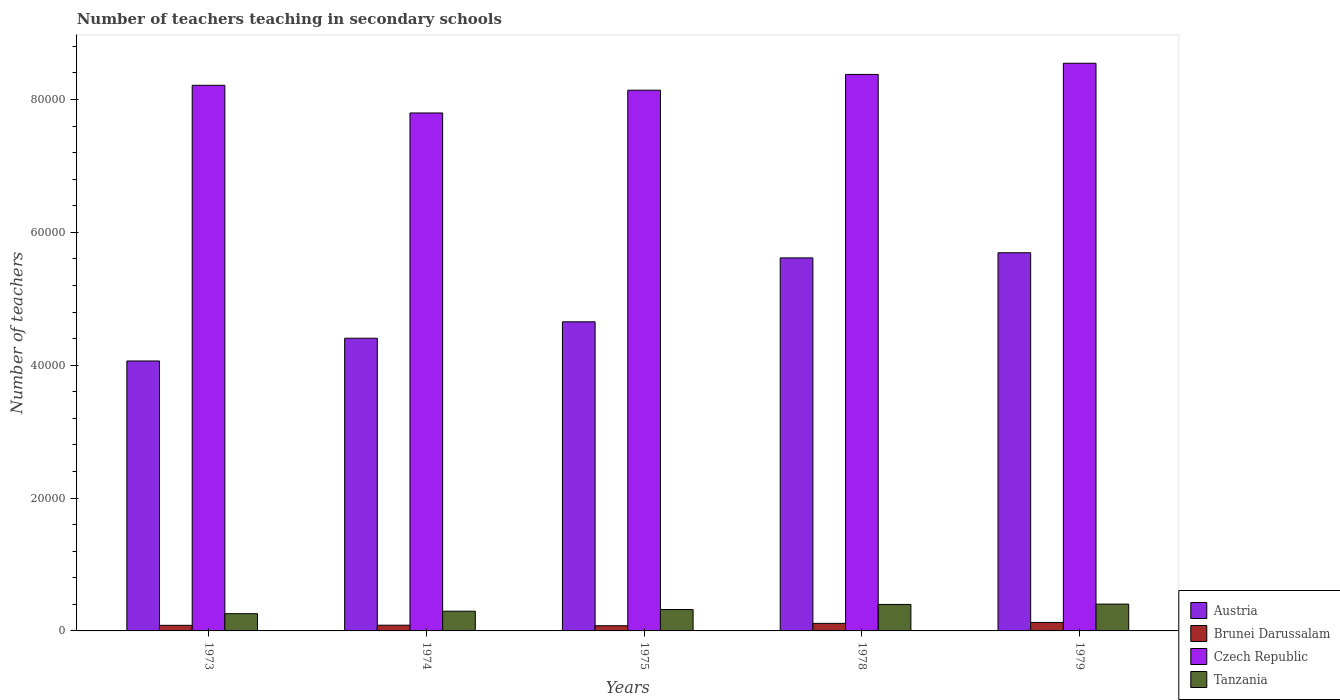How many groups of bars are there?
Make the answer very short. 5. How many bars are there on the 2nd tick from the left?
Offer a terse response. 4. What is the label of the 5th group of bars from the left?
Your answer should be very brief. 1979. What is the number of teachers teaching in secondary schools in Tanzania in 1973?
Give a very brief answer. 2596. Across all years, what is the maximum number of teachers teaching in secondary schools in Czech Republic?
Make the answer very short. 8.55e+04. Across all years, what is the minimum number of teachers teaching in secondary schools in Austria?
Give a very brief answer. 4.06e+04. In which year was the number of teachers teaching in secondary schools in Brunei Darussalam maximum?
Your response must be concise. 1979. In which year was the number of teachers teaching in secondary schools in Czech Republic minimum?
Make the answer very short. 1974. What is the total number of teachers teaching in secondary schools in Brunei Darussalam in the graph?
Offer a very short reply. 4899. What is the difference between the number of teachers teaching in secondary schools in Tanzania in 1974 and that in 1978?
Keep it short and to the point. -1018. What is the difference between the number of teachers teaching in secondary schools in Austria in 1974 and the number of teachers teaching in secondary schools in Czech Republic in 1979?
Give a very brief answer. -4.14e+04. What is the average number of teachers teaching in secondary schools in Brunei Darussalam per year?
Give a very brief answer. 979.8. In the year 1975, what is the difference between the number of teachers teaching in secondary schools in Austria and number of teachers teaching in secondary schools in Tanzania?
Offer a terse response. 4.33e+04. In how many years, is the number of teachers teaching in secondary schools in Brunei Darussalam greater than 20000?
Keep it short and to the point. 0. What is the ratio of the number of teachers teaching in secondary schools in Brunei Darussalam in 1975 to that in 1978?
Give a very brief answer. 0.69. What is the difference between the highest and the second highest number of teachers teaching in secondary schools in Czech Republic?
Your answer should be compact. 1681. What is the difference between the highest and the lowest number of teachers teaching in secondary schools in Tanzania?
Your answer should be very brief. 1442. Is the sum of the number of teachers teaching in secondary schools in Brunei Darussalam in 1973 and 1978 greater than the maximum number of teachers teaching in secondary schools in Austria across all years?
Your response must be concise. No. What does the 1st bar from the left in 1975 represents?
Offer a very short reply. Austria. Is it the case that in every year, the sum of the number of teachers teaching in secondary schools in Brunei Darussalam and number of teachers teaching in secondary schools in Tanzania is greater than the number of teachers teaching in secondary schools in Czech Republic?
Provide a short and direct response. No. How many bars are there?
Ensure brevity in your answer.  20. Are all the bars in the graph horizontal?
Your answer should be compact. No. How many years are there in the graph?
Make the answer very short. 5. Are the values on the major ticks of Y-axis written in scientific E-notation?
Ensure brevity in your answer.  No. Does the graph contain any zero values?
Provide a succinct answer. No. What is the title of the graph?
Your answer should be compact. Number of teachers teaching in secondary schools. Does "Mauritius" appear as one of the legend labels in the graph?
Make the answer very short. No. What is the label or title of the Y-axis?
Provide a short and direct response. Number of teachers. What is the Number of teachers in Austria in 1973?
Keep it short and to the point. 4.06e+04. What is the Number of teachers of Brunei Darussalam in 1973?
Provide a succinct answer. 844. What is the Number of teachers in Czech Republic in 1973?
Make the answer very short. 8.21e+04. What is the Number of teachers of Tanzania in 1973?
Keep it short and to the point. 2596. What is the Number of teachers in Austria in 1974?
Ensure brevity in your answer.  4.41e+04. What is the Number of teachers of Brunei Darussalam in 1974?
Your answer should be very brief. 859. What is the Number of teachers of Czech Republic in 1974?
Give a very brief answer. 7.80e+04. What is the Number of teachers of Tanzania in 1974?
Ensure brevity in your answer.  2967. What is the Number of teachers in Austria in 1975?
Make the answer very short. 4.65e+04. What is the Number of teachers in Brunei Darussalam in 1975?
Your answer should be compact. 782. What is the Number of teachers in Czech Republic in 1975?
Offer a terse response. 8.14e+04. What is the Number of teachers of Tanzania in 1975?
Your answer should be compact. 3218. What is the Number of teachers in Austria in 1978?
Your answer should be very brief. 5.62e+04. What is the Number of teachers in Brunei Darussalam in 1978?
Ensure brevity in your answer.  1138. What is the Number of teachers in Czech Republic in 1978?
Your answer should be very brief. 8.38e+04. What is the Number of teachers in Tanzania in 1978?
Keep it short and to the point. 3985. What is the Number of teachers in Austria in 1979?
Provide a succinct answer. 5.69e+04. What is the Number of teachers of Brunei Darussalam in 1979?
Your answer should be very brief. 1276. What is the Number of teachers in Czech Republic in 1979?
Offer a terse response. 8.55e+04. What is the Number of teachers in Tanzania in 1979?
Give a very brief answer. 4038. Across all years, what is the maximum Number of teachers of Austria?
Your response must be concise. 5.69e+04. Across all years, what is the maximum Number of teachers in Brunei Darussalam?
Your answer should be very brief. 1276. Across all years, what is the maximum Number of teachers of Czech Republic?
Ensure brevity in your answer.  8.55e+04. Across all years, what is the maximum Number of teachers in Tanzania?
Your answer should be very brief. 4038. Across all years, what is the minimum Number of teachers in Austria?
Provide a succinct answer. 4.06e+04. Across all years, what is the minimum Number of teachers in Brunei Darussalam?
Provide a succinct answer. 782. Across all years, what is the minimum Number of teachers of Czech Republic?
Give a very brief answer. 7.80e+04. Across all years, what is the minimum Number of teachers of Tanzania?
Make the answer very short. 2596. What is the total Number of teachers in Austria in the graph?
Keep it short and to the point. 2.44e+05. What is the total Number of teachers in Brunei Darussalam in the graph?
Offer a very short reply. 4899. What is the total Number of teachers of Czech Republic in the graph?
Offer a terse response. 4.11e+05. What is the total Number of teachers of Tanzania in the graph?
Your answer should be compact. 1.68e+04. What is the difference between the Number of teachers in Austria in 1973 and that in 1974?
Provide a succinct answer. -3423. What is the difference between the Number of teachers of Brunei Darussalam in 1973 and that in 1974?
Make the answer very short. -15. What is the difference between the Number of teachers of Czech Republic in 1973 and that in 1974?
Offer a terse response. 4167. What is the difference between the Number of teachers of Tanzania in 1973 and that in 1974?
Offer a very short reply. -371. What is the difference between the Number of teachers in Austria in 1973 and that in 1975?
Offer a very short reply. -5897. What is the difference between the Number of teachers in Czech Republic in 1973 and that in 1975?
Your answer should be compact. 741. What is the difference between the Number of teachers of Tanzania in 1973 and that in 1975?
Provide a succinct answer. -622. What is the difference between the Number of teachers of Austria in 1973 and that in 1978?
Offer a very short reply. -1.55e+04. What is the difference between the Number of teachers of Brunei Darussalam in 1973 and that in 1978?
Offer a terse response. -294. What is the difference between the Number of teachers in Czech Republic in 1973 and that in 1978?
Your answer should be compact. -1635. What is the difference between the Number of teachers in Tanzania in 1973 and that in 1978?
Your answer should be very brief. -1389. What is the difference between the Number of teachers of Austria in 1973 and that in 1979?
Your answer should be compact. -1.63e+04. What is the difference between the Number of teachers in Brunei Darussalam in 1973 and that in 1979?
Offer a terse response. -432. What is the difference between the Number of teachers of Czech Republic in 1973 and that in 1979?
Make the answer very short. -3316. What is the difference between the Number of teachers in Tanzania in 1973 and that in 1979?
Give a very brief answer. -1442. What is the difference between the Number of teachers in Austria in 1974 and that in 1975?
Your answer should be compact. -2474. What is the difference between the Number of teachers of Brunei Darussalam in 1974 and that in 1975?
Give a very brief answer. 77. What is the difference between the Number of teachers in Czech Republic in 1974 and that in 1975?
Give a very brief answer. -3426. What is the difference between the Number of teachers of Tanzania in 1974 and that in 1975?
Make the answer very short. -251. What is the difference between the Number of teachers in Austria in 1974 and that in 1978?
Give a very brief answer. -1.21e+04. What is the difference between the Number of teachers of Brunei Darussalam in 1974 and that in 1978?
Provide a short and direct response. -279. What is the difference between the Number of teachers in Czech Republic in 1974 and that in 1978?
Your answer should be compact. -5802. What is the difference between the Number of teachers in Tanzania in 1974 and that in 1978?
Keep it short and to the point. -1018. What is the difference between the Number of teachers of Austria in 1974 and that in 1979?
Offer a very short reply. -1.29e+04. What is the difference between the Number of teachers in Brunei Darussalam in 1974 and that in 1979?
Offer a very short reply. -417. What is the difference between the Number of teachers in Czech Republic in 1974 and that in 1979?
Your answer should be very brief. -7483. What is the difference between the Number of teachers in Tanzania in 1974 and that in 1979?
Your response must be concise. -1071. What is the difference between the Number of teachers of Austria in 1975 and that in 1978?
Provide a succinct answer. -9620. What is the difference between the Number of teachers in Brunei Darussalam in 1975 and that in 1978?
Provide a succinct answer. -356. What is the difference between the Number of teachers in Czech Republic in 1975 and that in 1978?
Offer a terse response. -2376. What is the difference between the Number of teachers in Tanzania in 1975 and that in 1978?
Ensure brevity in your answer.  -767. What is the difference between the Number of teachers in Austria in 1975 and that in 1979?
Give a very brief answer. -1.04e+04. What is the difference between the Number of teachers of Brunei Darussalam in 1975 and that in 1979?
Keep it short and to the point. -494. What is the difference between the Number of teachers of Czech Republic in 1975 and that in 1979?
Your answer should be compact. -4057. What is the difference between the Number of teachers of Tanzania in 1975 and that in 1979?
Your response must be concise. -820. What is the difference between the Number of teachers of Austria in 1978 and that in 1979?
Make the answer very short. -776. What is the difference between the Number of teachers in Brunei Darussalam in 1978 and that in 1979?
Keep it short and to the point. -138. What is the difference between the Number of teachers in Czech Republic in 1978 and that in 1979?
Your response must be concise. -1681. What is the difference between the Number of teachers in Tanzania in 1978 and that in 1979?
Ensure brevity in your answer.  -53. What is the difference between the Number of teachers of Austria in 1973 and the Number of teachers of Brunei Darussalam in 1974?
Make the answer very short. 3.98e+04. What is the difference between the Number of teachers in Austria in 1973 and the Number of teachers in Czech Republic in 1974?
Your answer should be compact. -3.73e+04. What is the difference between the Number of teachers of Austria in 1973 and the Number of teachers of Tanzania in 1974?
Keep it short and to the point. 3.77e+04. What is the difference between the Number of teachers in Brunei Darussalam in 1973 and the Number of teachers in Czech Republic in 1974?
Your answer should be compact. -7.71e+04. What is the difference between the Number of teachers in Brunei Darussalam in 1973 and the Number of teachers in Tanzania in 1974?
Give a very brief answer. -2123. What is the difference between the Number of teachers in Czech Republic in 1973 and the Number of teachers in Tanzania in 1974?
Provide a succinct answer. 7.92e+04. What is the difference between the Number of teachers of Austria in 1973 and the Number of teachers of Brunei Darussalam in 1975?
Your answer should be very brief. 3.99e+04. What is the difference between the Number of teachers of Austria in 1973 and the Number of teachers of Czech Republic in 1975?
Offer a very short reply. -4.08e+04. What is the difference between the Number of teachers in Austria in 1973 and the Number of teachers in Tanzania in 1975?
Offer a very short reply. 3.74e+04. What is the difference between the Number of teachers of Brunei Darussalam in 1973 and the Number of teachers of Czech Republic in 1975?
Offer a very short reply. -8.06e+04. What is the difference between the Number of teachers in Brunei Darussalam in 1973 and the Number of teachers in Tanzania in 1975?
Offer a very short reply. -2374. What is the difference between the Number of teachers in Czech Republic in 1973 and the Number of teachers in Tanzania in 1975?
Offer a terse response. 7.89e+04. What is the difference between the Number of teachers of Austria in 1973 and the Number of teachers of Brunei Darussalam in 1978?
Your response must be concise. 3.95e+04. What is the difference between the Number of teachers in Austria in 1973 and the Number of teachers in Czech Republic in 1978?
Make the answer very short. -4.31e+04. What is the difference between the Number of teachers in Austria in 1973 and the Number of teachers in Tanzania in 1978?
Offer a very short reply. 3.66e+04. What is the difference between the Number of teachers in Brunei Darussalam in 1973 and the Number of teachers in Czech Republic in 1978?
Make the answer very short. -8.29e+04. What is the difference between the Number of teachers in Brunei Darussalam in 1973 and the Number of teachers in Tanzania in 1978?
Make the answer very short. -3141. What is the difference between the Number of teachers of Czech Republic in 1973 and the Number of teachers of Tanzania in 1978?
Offer a very short reply. 7.82e+04. What is the difference between the Number of teachers in Austria in 1973 and the Number of teachers in Brunei Darussalam in 1979?
Offer a very short reply. 3.94e+04. What is the difference between the Number of teachers of Austria in 1973 and the Number of teachers of Czech Republic in 1979?
Provide a succinct answer. -4.48e+04. What is the difference between the Number of teachers of Austria in 1973 and the Number of teachers of Tanzania in 1979?
Make the answer very short. 3.66e+04. What is the difference between the Number of teachers in Brunei Darussalam in 1973 and the Number of teachers in Czech Republic in 1979?
Provide a short and direct response. -8.46e+04. What is the difference between the Number of teachers in Brunei Darussalam in 1973 and the Number of teachers in Tanzania in 1979?
Make the answer very short. -3194. What is the difference between the Number of teachers in Czech Republic in 1973 and the Number of teachers in Tanzania in 1979?
Give a very brief answer. 7.81e+04. What is the difference between the Number of teachers in Austria in 1974 and the Number of teachers in Brunei Darussalam in 1975?
Ensure brevity in your answer.  4.33e+04. What is the difference between the Number of teachers in Austria in 1974 and the Number of teachers in Czech Republic in 1975?
Your answer should be compact. -3.73e+04. What is the difference between the Number of teachers in Austria in 1974 and the Number of teachers in Tanzania in 1975?
Offer a very short reply. 4.08e+04. What is the difference between the Number of teachers of Brunei Darussalam in 1974 and the Number of teachers of Czech Republic in 1975?
Provide a short and direct response. -8.05e+04. What is the difference between the Number of teachers of Brunei Darussalam in 1974 and the Number of teachers of Tanzania in 1975?
Give a very brief answer. -2359. What is the difference between the Number of teachers in Czech Republic in 1974 and the Number of teachers in Tanzania in 1975?
Ensure brevity in your answer.  7.48e+04. What is the difference between the Number of teachers of Austria in 1974 and the Number of teachers of Brunei Darussalam in 1978?
Provide a succinct answer. 4.29e+04. What is the difference between the Number of teachers in Austria in 1974 and the Number of teachers in Czech Republic in 1978?
Offer a very short reply. -3.97e+04. What is the difference between the Number of teachers of Austria in 1974 and the Number of teachers of Tanzania in 1978?
Your answer should be compact. 4.01e+04. What is the difference between the Number of teachers in Brunei Darussalam in 1974 and the Number of teachers in Czech Republic in 1978?
Offer a very short reply. -8.29e+04. What is the difference between the Number of teachers of Brunei Darussalam in 1974 and the Number of teachers of Tanzania in 1978?
Your response must be concise. -3126. What is the difference between the Number of teachers of Czech Republic in 1974 and the Number of teachers of Tanzania in 1978?
Offer a very short reply. 7.40e+04. What is the difference between the Number of teachers of Austria in 1974 and the Number of teachers of Brunei Darussalam in 1979?
Your answer should be very brief. 4.28e+04. What is the difference between the Number of teachers in Austria in 1974 and the Number of teachers in Czech Republic in 1979?
Offer a terse response. -4.14e+04. What is the difference between the Number of teachers of Austria in 1974 and the Number of teachers of Tanzania in 1979?
Your answer should be very brief. 4.00e+04. What is the difference between the Number of teachers of Brunei Darussalam in 1974 and the Number of teachers of Czech Republic in 1979?
Your response must be concise. -8.46e+04. What is the difference between the Number of teachers of Brunei Darussalam in 1974 and the Number of teachers of Tanzania in 1979?
Give a very brief answer. -3179. What is the difference between the Number of teachers in Czech Republic in 1974 and the Number of teachers in Tanzania in 1979?
Offer a terse response. 7.39e+04. What is the difference between the Number of teachers of Austria in 1975 and the Number of teachers of Brunei Darussalam in 1978?
Keep it short and to the point. 4.54e+04. What is the difference between the Number of teachers of Austria in 1975 and the Number of teachers of Czech Republic in 1978?
Keep it short and to the point. -3.72e+04. What is the difference between the Number of teachers in Austria in 1975 and the Number of teachers in Tanzania in 1978?
Your answer should be compact. 4.25e+04. What is the difference between the Number of teachers in Brunei Darussalam in 1975 and the Number of teachers in Czech Republic in 1978?
Provide a short and direct response. -8.30e+04. What is the difference between the Number of teachers in Brunei Darussalam in 1975 and the Number of teachers in Tanzania in 1978?
Offer a very short reply. -3203. What is the difference between the Number of teachers of Czech Republic in 1975 and the Number of teachers of Tanzania in 1978?
Provide a short and direct response. 7.74e+04. What is the difference between the Number of teachers in Austria in 1975 and the Number of teachers in Brunei Darussalam in 1979?
Offer a very short reply. 4.53e+04. What is the difference between the Number of teachers of Austria in 1975 and the Number of teachers of Czech Republic in 1979?
Ensure brevity in your answer.  -3.89e+04. What is the difference between the Number of teachers in Austria in 1975 and the Number of teachers in Tanzania in 1979?
Give a very brief answer. 4.25e+04. What is the difference between the Number of teachers in Brunei Darussalam in 1975 and the Number of teachers in Czech Republic in 1979?
Your answer should be compact. -8.47e+04. What is the difference between the Number of teachers of Brunei Darussalam in 1975 and the Number of teachers of Tanzania in 1979?
Ensure brevity in your answer.  -3256. What is the difference between the Number of teachers of Czech Republic in 1975 and the Number of teachers of Tanzania in 1979?
Offer a terse response. 7.74e+04. What is the difference between the Number of teachers in Austria in 1978 and the Number of teachers in Brunei Darussalam in 1979?
Provide a succinct answer. 5.49e+04. What is the difference between the Number of teachers of Austria in 1978 and the Number of teachers of Czech Republic in 1979?
Offer a terse response. -2.93e+04. What is the difference between the Number of teachers of Austria in 1978 and the Number of teachers of Tanzania in 1979?
Offer a terse response. 5.21e+04. What is the difference between the Number of teachers of Brunei Darussalam in 1978 and the Number of teachers of Czech Republic in 1979?
Your response must be concise. -8.43e+04. What is the difference between the Number of teachers in Brunei Darussalam in 1978 and the Number of teachers in Tanzania in 1979?
Ensure brevity in your answer.  -2900. What is the difference between the Number of teachers in Czech Republic in 1978 and the Number of teachers in Tanzania in 1979?
Ensure brevity in your answer.  7.97e+04. What is the average Number of teachers in Austria per year?
Provide a succinct answer. 4.89e+04. What is the average Number of teachers in Brunei Darussalam per year?
Provide a succinct answer. 979.8. What is the average Number of teachers in Czech Republic per year?
Your response must be concise. 8.21e+04. What is the average Number of teachers in Tanzania per year?
Your answer should be compact. 3360.8. In the year 1973, what is the difference between the Number of teachers of Austria and Number of teachers of Brunei Darussalam?
Your answer should be compact. 3.98e+04. In the year 1973, what is the difference between the Number of teachers of Austria and Number of teachers of Czech Republic?
Provide a succinct answer. -4.15e+04. In the year 1973, what is the difference between the Number of teachers of Austria and Number of teachers of Tanzania?
Offer a terse response. 3.80e+04. In the year 1973, what is the difference between the Number of teachers of Brunei Darussalam and Number of teachers of Czech Republic?
Offer a terse response. -8.13e+04. In the year 1973, what is the difference between the Number of teachers in Brunei Darussalam and Number of teachers in Tanzania?
Offer a terse response. -1752. In the year 1973, what is the difference between the Number of teachers in Czech Republic and Number of teachers in Tanzania?
Your response must be concise. 7.95e+04. In the year 1974, what is the difference between the Number of teachers in Austria and Number of teachers in Brunei Darussalam?
Your response must be concise. 4.32e+04. In the year 1974, what is the difference between the Number of teachers of Austria and Number of teachers of Czech Republic?
Your answer should be compact. -3.39e+04. In the year 1974, what is the difference between the Number of teachers in Austria and Number of teachers in Tanzania?
Provide a succinct answer. 4.11e+04. In the year 1974, what is the difference between the Number of teachers in Brunei Darussalam and Number of teachers in Czech Republic?
Your answer should be compact. -7.71e+04. In the year 1974, what is the difference between the Number of teachers of Brunei Darussalam and Number of teachers of Tanzania?
Offer a terse response. -2108. In the year 1974, what is the difference between the Number of teachers of Czech Republic and Number of teachers of Tanzania?
Keep it short and to the point. 7.50e+04. In the year 1975, what is the difference between the Number of teachers of Austria and Number of teachers of Brunei Darussalam?
Give a very brief answer. 4.57e+04. In the year 1975, what is the difference between the Number of teachers in Austria and Number of teachers in Czech Republic?
Provide a succinct answer. -3.49e+04. In the year 1975, what is the difference between the Number of teachers in Austria and Number of teachers in Tanzania?
Ensure brevity in your answer.  4.33e+04. In the year 1975, what is the difference between the Number of teachers of Brunei Darussalam and Number of teachers of Czech Republic?
Your response must be concise. -8.06e+04. In the year 1975, what is the difference between the Number of teachers in Brunei Darussalam and Number of teachers in Tanzania?
Provide a succinct answer. -2436. In the year 1975, what is the difference between the Number of teachers in Czech Republic and Number of teachers in Tanzania?
Offer a very short reply. 7.82e+04. In the year 1978, what is the difference between the Number of teachers in Austria and Number of teachers in Brunei Darussalam?
Give a very brief answer. 5.50e+04. In the year 1978, what is the difference between the Number of teachers in Austria and Number of teachers in Czech Republic?
Your answer should be compact. -2.76e+04. In the year 1978, what is the difference between the Number of teachers in Austria and Number of teachers in Tanzania?
Offer a terse response. 5.22e+04. In the year 1978, what is the difference between the Number of teachers in Brunei Darussalam and Number of teachers in Czech Republic?
Ensure brevity in your answer.  -8.26e+04. In the year 1978, what is the difference between the Number of teachers in Brunei Darussalam and Number of teachers in Tanzania?
Your answer should be compact. -2847. In the year 1978, what is the difference between the Number of teachers of Czech Republic and Number of teachers of Tanzania?
Keep it short and to the point. 7.98e+04. In the year 1979, what is the difference between the Number of teachers in Austria and Number of teachers in Brunei Darussalam?
Your response must be concise. 5.57e+04. In the year 1979, what is the difference between the Number of teachers in Austria and Number of teachers in Czech Republic?
Your answer should be compact. -2.85e+04. In the year 1979, what is the difference between the Number of teachers of Austria and Number of teachers of Tanzania?
Your response must be concise. 5.29e+04. In the year 1979, what is the difference between the Number of teachers in Brunei Darussalam and Number of teachers in Czech Republic?
Make the answer very short. -8.42e+04. In the year 1979, what is the difference between the Number of teachers of Brunei Darussalam and Number of teachers of Tanzania?
Provide a succinct answer. -2762. In the year 1979, what is the difference between the Number of teachers of Czech Republic and Number of teachers of Tanzania?
Provide a succinct answer. 8.14e+04. What is the ratio of the Number of teachers in Austria in 1973 to that in 1974?
Provide a succinct answer. 0.92. What is the ratio of the Number of teachers of Brunei Darussalam in 1973 to that in 1974?
Your response must be concise. 0.98. What is the ratio of the Number of teachers in Czech Republic in 1973 to that in 1974?
Make the answer very short. 1.05. What is the ratio of the Number of teachers of Austria in 1973 to that in 1975?
Ensure brevity in your answer.  0.87. What is the ratio of the Number of teachers in Brunei Darussalam in 1973 to that in 1975?
Keep it short and to the point. 1.08. What is the ratio of the Number of teachers of Czech Republic in 1973 to that in 1975?
Keep it short and to the point. 1.01. What is the ratio of the Number of teachers in Tanzania in 1973 to that in 1975?
Your response must be concise. 0.81. What is the ratio of the Number of teachers in Austria in 1973 to that in 1978?
Keep it short and to the point. 0.72. What is the ratio of the Number of teachers in Brunei Darussalam in 1973 to that in 1978?
Provide a short and direct response. 0.74. What is the ratio of the Number of teachers in Czech Republic in 1973 to that in 1978?
Your answer should be compact. 0.98. What is the ratio of the Number of teachers of Tanzania in 1973 to that in 1978?
Offer a very short reply. 0.65. What is the ratio of the Number of teachers of Austria in 1973 to that in 1979?
Your answer should be compact. 0.71. What is the ratio of the Number of teachers of Brunei Darussalam in 1973 to that in 1979?
Provide a succinct answer. 0.66. What is the ratio of the Number of teachers of Czech Republic in 1973 to that in 1979?
Provide a succinct answer. 0.96. What is the ratio of the Number of teachers of Tanzania in 1973 to that in 1979?
Provide a succinct answer. 0.64. What is the ratio of the Number of teachers in Austria in 1974 to that in 1975?
Provide a short and direct response. 0.95. What is the ratio of the Number of teachers of Brunei Darussalam in 1974 to that in 1975?
Provide a short and direct response. 1.1. What is the ratio of the Number of teachers of Czech Republic in 1974 to that in 1975?
Give a very brief answer. 0.96. What is the ratio of the Number of teachers in Tanzania in 1974 to that in 1975?
Make the answer very short. 0.92. What is the ratio of the Number of teachers of Austria in 1974 to that in 1978?
Ensure brevity in your answer.  0.78. What is the ratio of the Number of teachers in Brunei Darussalam in 1974 to that in 1978?
Provide a succinct answer. 0.75. What is the ratio of the Number of teachers of Czech Republic in 1974 to that in 1978?
Ensure brevity in your answer.  0.93. What is the ratio of the Number of teachers in Tanzania in 1974 to that in 1978?
Offer a terse response. 0.74. What is the ratio of the Number of teachers of Austria in 1974 to that in 1979?
Provide a succinct answer. 0.77. What is the ratio of the Number of teachers of Brunei Darussalam in 1974 to that in 1979?
Your answer should be very brief. 0.67. What is the ratio of the Number of teachers in Czech Republic in 1974 to that in 1979?
Provide a succinct answer. 0.91. What is the ratio of the Number of teachers in Tanzania in 1974 to that in 1979?
Make the answer very short. 0.73. What is the ratio of the Number of teachers in Austria in 1975 to that in 1978?
Provide a succinct answer. 0.83. What is the ratio of the Number of teachers in Brunei Darussalam in 1975 to that in 1978?
Offer a terse response. 0.69. What is the ratio of the Number of teachers of Czech Republic in 1975 to that in 1978?
Provide a succinct answer. 0.97. What is the ratio of the Number of teachers in Tanzania in 1975 to that in 1978?
Make the answer very short. 0.81. What is the ratio of the Number of teachers in Austria in 1975 to that in 1979?
Make the answer very short. 0.82. What is the ratio of the Number of teachers in Brunei Darussalam in 1975 to that in 1979?
Provide a succinct answer. 0.61. What is the ratio of the Number of teachers of Czech Republic in 1975 to that in 1979?
Your answer should be very brief. 0.95. What is the ratio of the Number of teachers in Tanzania in 1975 to that in 1979?
Your answer should be compact. 0.8. What is the ratio of the Number of teachers of Austria in 1978 to that in 1979?
Offer a very short reply. 0.99. What is the ratio of the Number of teachers of Brunei Darussalam in 1978 to that in 1979?
Offer a very short reply. 0.89. What is the ratio of the Number of teachers in Czech Republic in 1978 to that in 1979?
Offer a terse response. 0.98. What is the ratio of the Number of teachers of Tanzania in 1978 to that in 1979?
Keep it short and to the point. 0.99. What is the difference between the highest and the second highest Number of teachers in Austria?
Provide a short and direct response. 776. What is the difference between the highest and the second highest Number of teachers of Brunei Darussalam?
Keep it short and to the point. 138. What is the difference between the highest and the second highest Number of teachers in Czech Republic?
Keep it short and to the point. 1681. What is the difference between the highest and the second highest Number of teachers in Tanzania?
Give a very brief answer. 53. What is the difference between the highest and the lowest Number of teachers in Austria?
Your response must be concise. 1.63e+04. What is the difference between the highest and the lowest Number of teachers in Brunei Darussalam?
Offer a terse response. 494. What is the difference between the highest and the lowest Number of teachers in Czech Republic?
Give a very brief answer. 7483. What is the difference between the highest and the lowest Number of teachers of Tanzania?
Provide a short and direct response. 1442. 